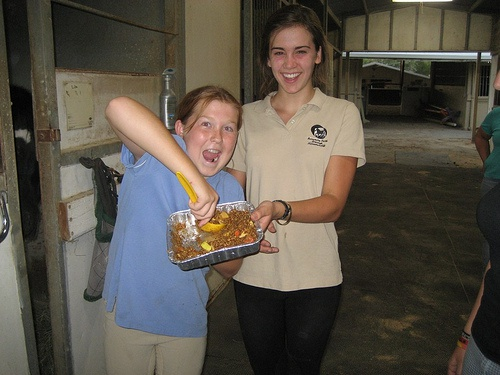Describe the objects in this image and their specific colors. I can see people in black, tan, and gray tones, people in black and gray tones, people in black, gray, and maroon tones, horse in black and gray tones, and people in black, teal, and maroon tones in this image. 